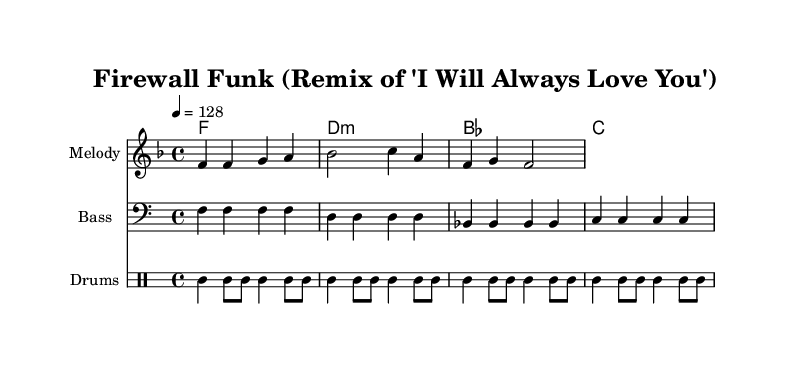What is the key signature of this music? The key signature is indicated by the number of sharps or flats shown on the staff. In this case, it shows one flat, which signifies F major.
Answer: F major What is the time signature of this music? The time signature is indicated at the beginning of the staff as two numbers stacked on top of each other. In this sheet music, it shows 4 over 4, meaning four beats per measure and a quarter note gets one beat.
Answer: 4/4 What is the tempo of the piece? The tempo is indicated at the beginning of the score with a marking showing the speed of the piece. This sheet music states "4 = 128," indicating a quarter note should be played at a rate of 128 beats per minute.
Answer: 128 How many bars are in the melody? To find the number of bars, count the groupings of notes and rests separated by vertical lines (bar lines). The melody section has four distinct measures, each separated by such lines.
Answer: 4 What is the dominant chord used in the harmony? The dominant chord can usually be found by looking at the chord progression; here, the D minor chord is indicated, which serves as the dominant in F major.
Answer: D minor Which instrument plays the bass line? The bass line is clearly indicated with "Bass" written above the staff, showing that this line is specifically for bass instruments to play.
Answer: Bass What is the name of the remix represented in this piece? The title of the piece is presented at the top of the sheet music under the header. It states "Firewall Funk (Remix of 'I Will Always Love You')."
Answer: Firewall Funk 